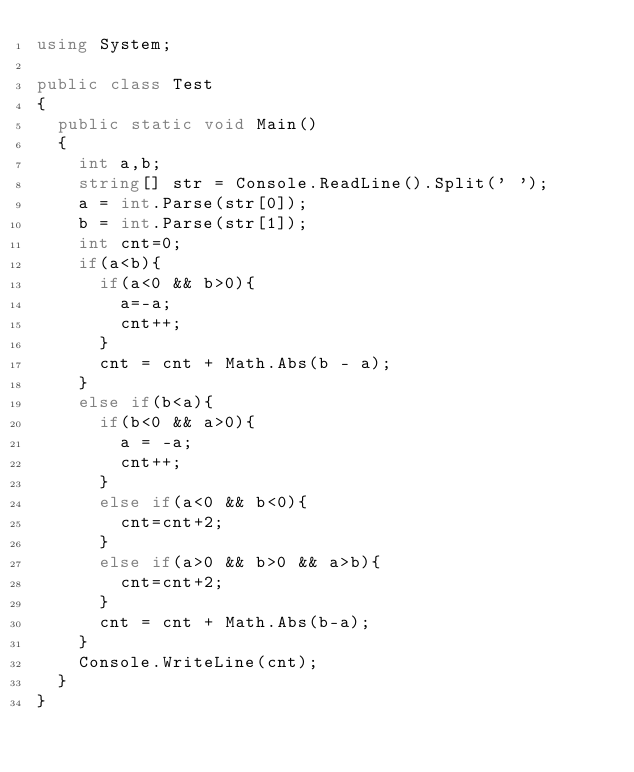Convert code to text. <code><loc_0><loc_0><loc_500><loc_500><_C#_>using System;

public class Test
{
	public static void Main()
	{
		int a,b;
		string[] str = Console.ReadLine().Split(' ');
		a = int.Parse(str[0]);
		b = int.Parse(str[1]);
		int cnt=0;
		if(a<b){
			if(a<0 && b>0){
				a=-a;
				cnt++;
			}
			cnt = cnt + Math.Abs(b - a);
		}
		else if(b<a){
			if(b<0 && a>0){
				a = -a;
				cnt++;
			}
			else if(a<0 && b<0){
				cnt=cnt+2;
			}
			else if(a>0 && b>0 && a>b){
				cnt=cnt+2;
			}
			cnt = cnt + Math.Abs(b-a);
		}
		Console.WriteLine(cnt);
	}
}</code> 